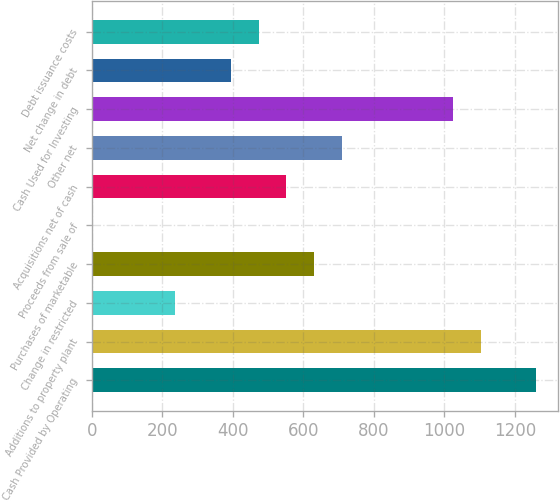Convert chart to OTSL. <chart><loc_0><loc_0><loc_500><loc_500><bar_chart><fcel>Cash Provided by Operating<fcel>Additions to property plant<fcel>Change in restricted<fcel>Purchases of marketable<fcel>Proceeds from sale of<fcel>Acquisitions net of cash<fcel>Other net<fcel>Cash Used for Investing<fcel>Net change in debt<fcel>Debt issuance costs<nl><fcel>1260.56<fcel>1103.04<fcel>236.68<fcel>630.48<fcel>0.4<fcel>551.72<fcel>709.24<fcel>1024.28<fcel>394.2<fcel>472.96<nl></chart> 